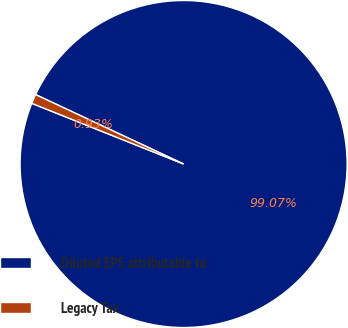Convert chart to OTSL. <chart><loc_0><loc_0><loc_500><loc_500><pie_chart><fcel>Diluted EPS attributable to<fcel>Legacy Tax<nl><fcel>99.07%<fcel>0.93%<nl></chart> 